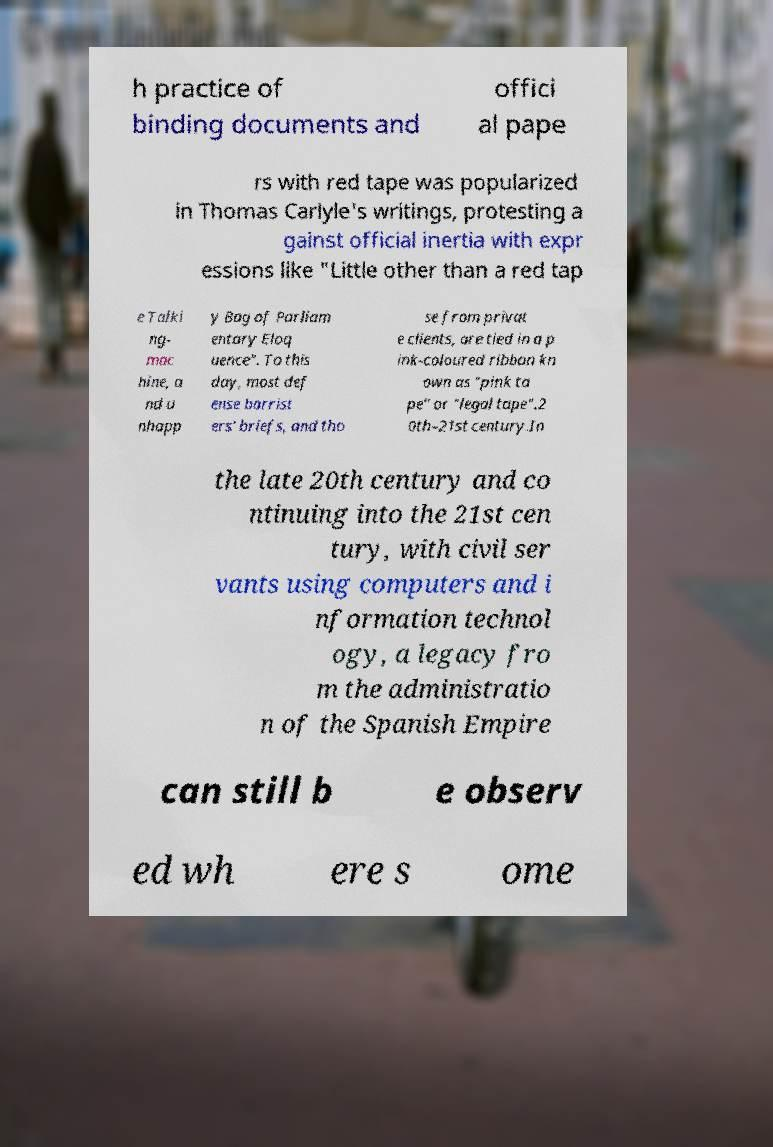Could you extract and type out the text from this image? h practice of binding documents and offici al pape rs with red tape was popularized in Thomas Carlyle's writings, protesting a gainst official inertia with expr essions like "Little other than a red tap e Talki ng- mac hine, a nd u nhapp y Bag of Parliam entary Eloq uence". To this day, most def ense barrist ers' briefs, and tho se from privat e clients, are tied in a p ink-coloured ribbon kn own as "pink ta pe" or "legal tape".2 0th–21st century.In the late 20th century and co ntinuing into the 21st cen tury, with civil ser vants using computers and i nformation technol ogy, a legacy fro m the administratio n of the Spanish Empire can still b e observ ed wh ere s ome 